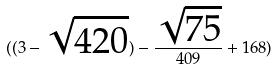Convert formula to latex. <formula><loc_0><loc_0><loc_500><loc_500>( ( 3 - \sqrt { 4 2 0 } ) - \frac { \sqrt { 7 5 } } { 4 0 9 } + 1 6 8 )</formula> 